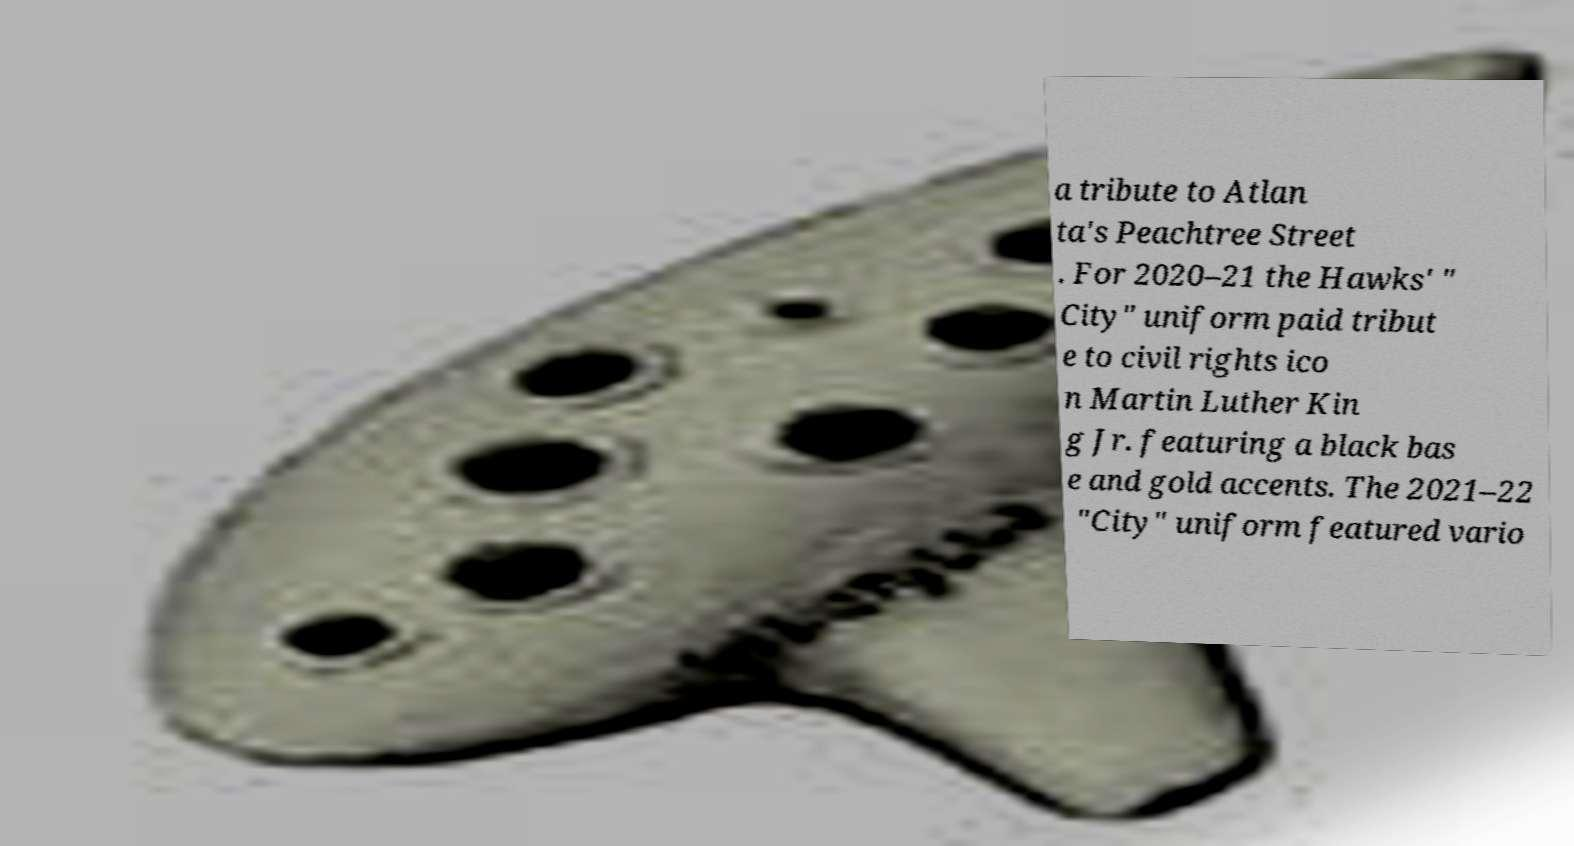Could you assist in decoding the text presented in this image and type it out clearly? a tribute to Atlan ta's Peachtree Street . For 2020–21 the Hawks' " City" uniform paid tribut e to civil rights ico n Martin Luther Kin g Jr. featuring a black bas e and gold accents. The 2021–22 "City" uniform featured vario 